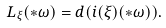Convert formula to latex. <formula><loc_0><loc_0><loc_500><loc_500>L _ { \xi } ( \ast \omega ) = d ( i ( \xi ) ( \ast \omega ) ) .</formula> 